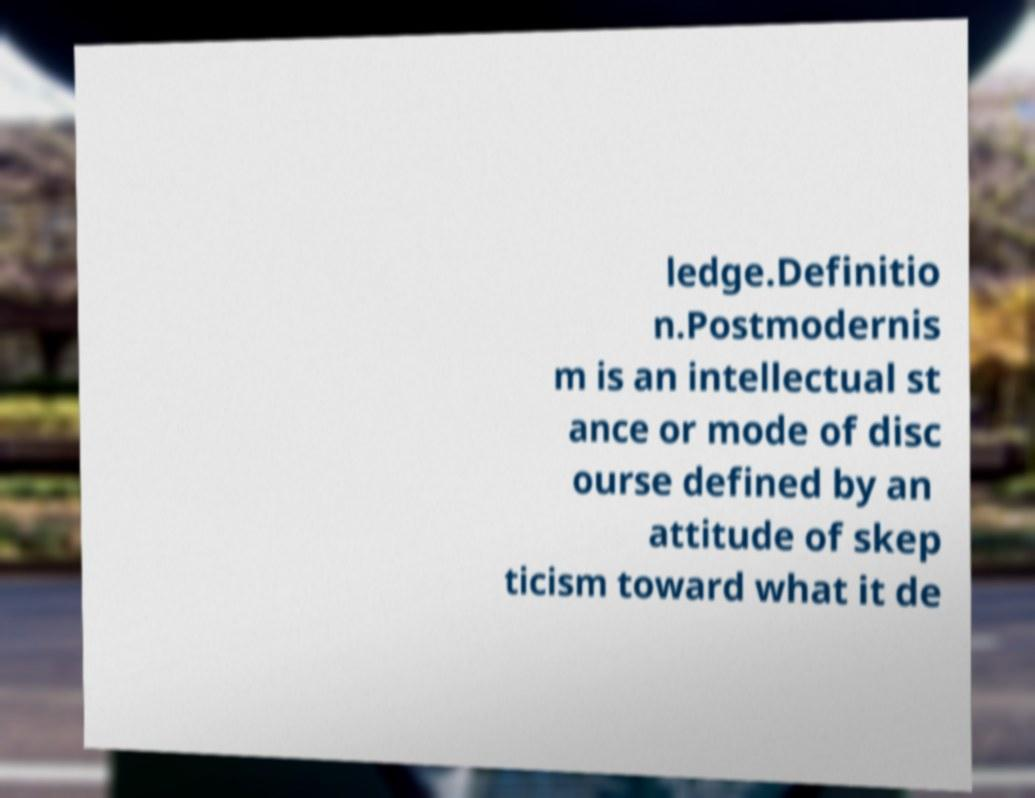Please read and relay the text visible in this image. What does it say? ledge.Definitio n.Postmodernis m is an intellectual st ance or mode of disc ourse defined by an attitude of skep ticism toward what it de 